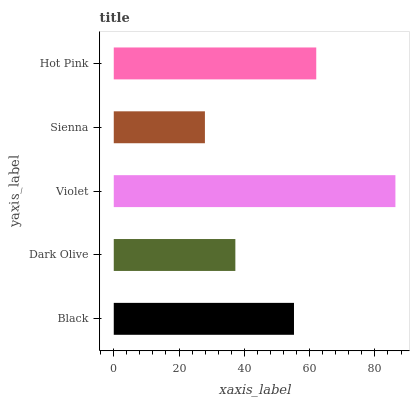Is Sienna the minimum?
Answer yes or no. Yes. Is Violet the maximum?
Answer yes or no. Yes. Is Dark Olive the minimum?
Answer yes or no. No. Is Dark Olive the maximum?
Answer yes or no. No. Is Black greater than Dark Olive?
Answer yes or no. Yes. Is Dark Olive less than Black?
Answer yes or no. Yes. Is Dark Olive greater than Black?
Answer yes or no. No. Is Black less than Dark Olive?
Answer yes or no. No. Is Black the high median?
Answer yes or no. Yes. Is Black the low median?
Answer yes or no. Yes. Is Sienna the high median?
Answer yes or no. No. Is Violet the low median?
Answer yes or no. No. 